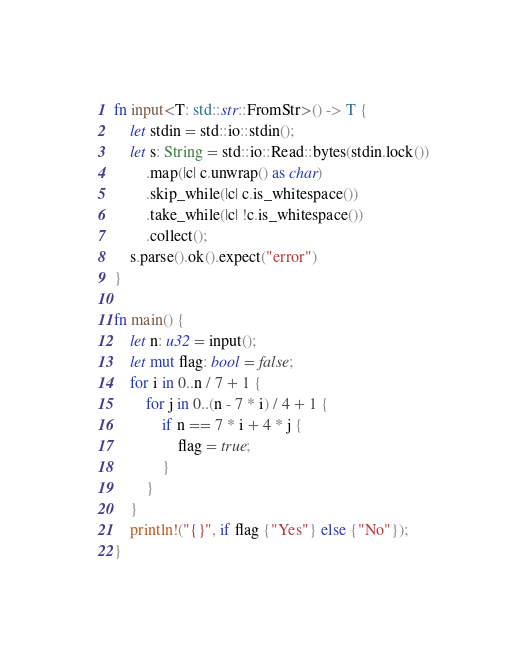Convert code to text. <code><loc_0><loc_0><loc_500><loc_500><_Rust_>fn input<T: std::str::FromStr>() -> T {
    let stdin = std::io::stdin();
    let s: String = std::io::Read::bytes(stdin.lock())
        .map(|c| c.unwrap() as char)
        .skip_while(|c| c.is_whitespace())
        .take_while(|c| !c.is_whitespace())
        .collect();
    s.parse().ok().expect("error")
}

fn main() {
    let n: u32 = input();
    let mut flag: bool = false;
    for i in 0..n / 7 + 1 {
        for j in 0..(n - 7 * i) / 4 + 1 {
            if n == 7 * i + 4 * j {
                flag = true;
            }
        }
    }
    println!("{}", if flag {"Yes"} else {"No"});
}</code> 